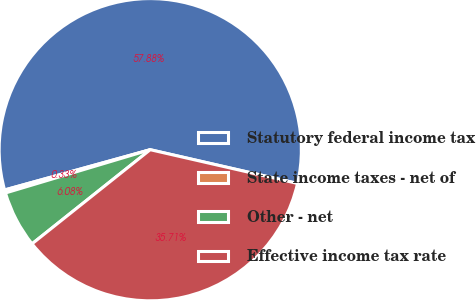<chart> <loc_0><loc_0><loc_500><loc_500><pie_chart><fcel>Statutory federal income tax<fcel>State income taxes - net of<fcel>Other - net<fcel>Effective income tax rate<nl><fcel>57.87%<fcel>0.33%<fcel>6.08%<fcel>35.71%<nl></chart> 